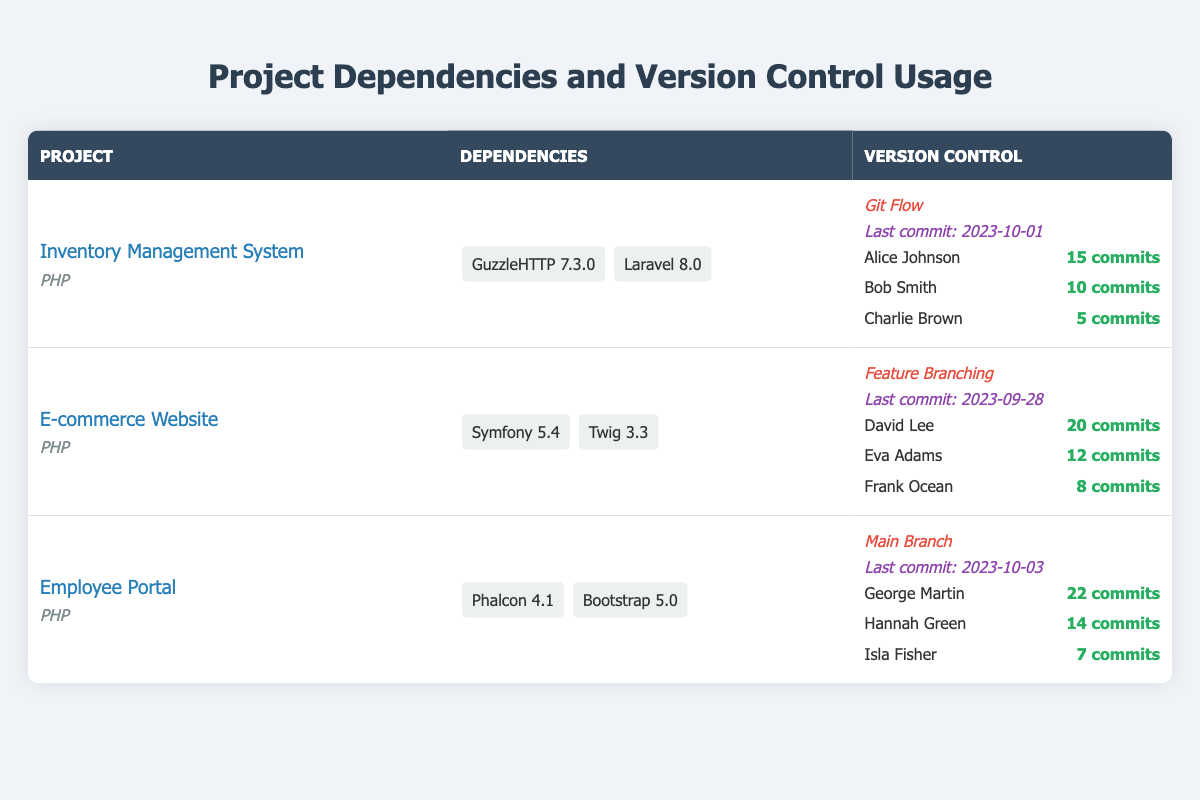What is the latest commit date for the "E-commerce Website" project? The table lists the last commit date for the "E-commerce Website" project as 2023-09-28.
Answer: 2023-09-28 Which project uses the "Git Flow" branching strategy? The table indicates that the "Inventory Management System" utilizes the "Git Flow" branching strategy.
Answer: Inventory Management System How many commits did George Martin make on the "Employee Portal" project? By reviewing the team members for the "Employee Portal" project in the table, George Martin has a commit count of 22.
Answer: 22 Which project has the highest total commit count among team members? The total commits for each project are: Inventory Management System (30), E-commerce Website (40), Employee Portal (43). The highest is from the Employee Portal with 43 commits.
Answer: Employee Portal Is Phalcon listed as a dependency for any project? The table shows that Phalcon is indeed listed as a dependency under the "Employee Portal" project.
Answer: Yes What is the average number of commits made by team members for the "Inventory Management System"? The total commits for the Inventory Management System are 15 + 10 + 5 = 30. There are 3 team members, so the average is 30 / 3 = 10.
Answer: 10 Which framework has a dependency listed with version 5.4? The "Symfony" framework with version 5.4 is listed as a dependency for the "E-commerce Website" project.
Answer: E-commerce Website How many commits were made in total for projects having a "Feature Branching" strategy? For "E-commerce Website," the total commits are 20 (David Lee) + 12 (Eva Adams) + 8 (Frank Ocean) = 40. Therefore, the total is 40 commits for projects using "Feature Branching."
Answer: 40 Which project has the oldest last commit date? Comparing the last commit dates, 2023-10-01 (Inventory Management System), 2023-09-28 (E-commerce Website), and 2023-10-03 (Employee Portal), the oldest is 2023-09-28 for the E-commerce Website.
Answer: E-commerce Website Who made the least number of commits in the "Employee Portal" project? From the table, Isla Fisher made the least number of commits, totaling 7.
Answer: Isla Fisher 